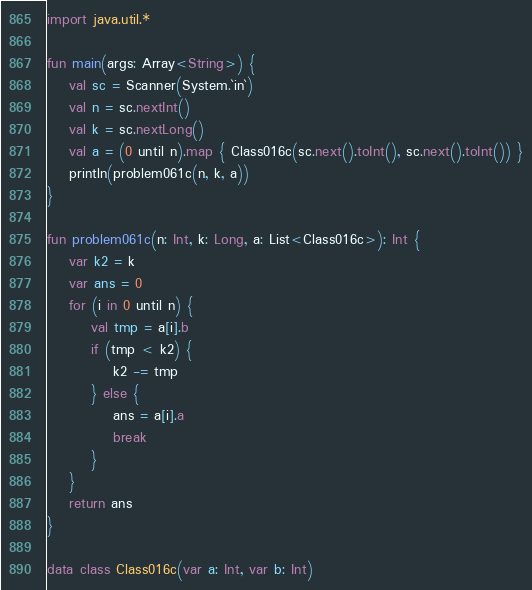<code> <loc_0><loc_0><loc_500><loc_500><_Kotlin_>import java.util.*

fun main(args: Array<String>) {
    val sc = Scanner(System.`in`)
    val n = sc.nextInt()
    val k = sc.nextLong()
    val a = (0 until n).map { Class016c(sc.next().toInt(), sc.next().toInt()) }
    println(problem061c(n, k, a))
}

fun problem061c(n: Int, k: Long, a: List<Class016c>): Int {
    var k2 = k
    var ans = 0
    for (i in 0 until n) {
        val tmp = a[i].b
        if (tmp < k2) {
            k2 -= tmp
        } else {
            ans = a[i].a
            break
        }
    }
    return ans
}

data class Class016c(var a: Int, var b: Int)</code> 